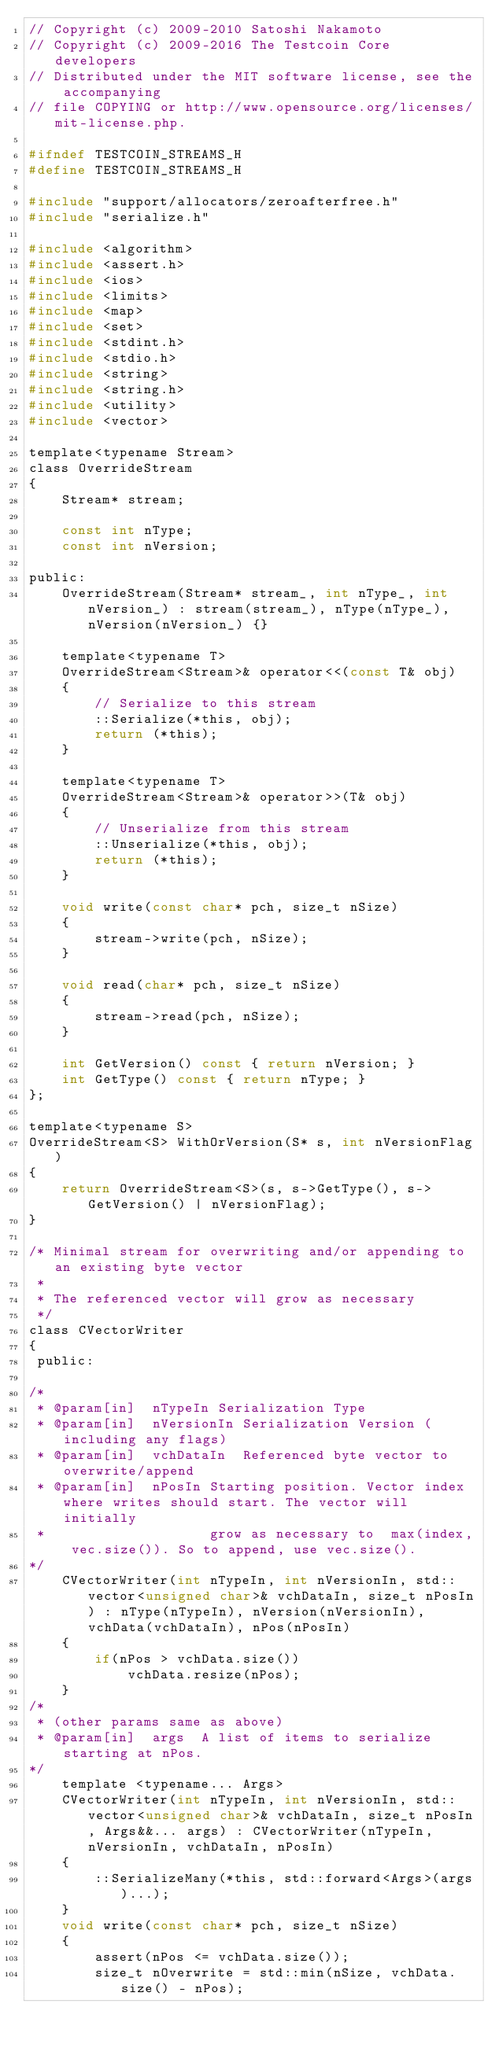<code> <loc_0><loc_0><loc_500><loc_500><_C_>// Copyright (c) 2009-2010 Satoshi Nakamoto
// Copyright (c) 2009-2016 The Testcoin Core developers
// Distributed under the MIT software license, see the accompanying
// file COPYING or http://www.opensource.org/licenses/mit-license.php.

#ifndef TESTCOIN_STREAMS_H
#define TESTCOIN_STREAMS_H

#include "support/allocators/zeroafterfree.h"
#include "serialize.h"

#include <algorithm>
#include <assert.h>
#include <ios>
#include <limits>
#include <map>
#include <set>
#include <stdint.h>
#include <stdio.h>
#include <string>
#include <string.h>
#include <utility>
#include <vector>

template<typename Stream>
class OverrideStream
{
    Stream* stream;

    const int nType;
    const int nVersion;

public:
    OverrideStream(Stream* stream_, int nType_, int nVersion_) : stream(stream_), nType(nType_), nVersion(nVersion_) {}

    template<typename T>
    OverrideStream<Stream>& operator<<(const T& obj)
    {
        // Serialize to this stream
        ::Serialize(*this, obj);
        return (*this);
    }

    template<typename T>
    OverrideStream<Stream>& operator>>(T& obj)
    {
        // Unserialize from this stream
        ::Unserialize(*this, obj);
        return (*this);
    }

    void write(const char* pch, size_t nSize)
    {
        stream->write(pch, nSize);
    }

    void read(char* pch, size_t nSize)
    {
        stream->read(pch, nSize);
    }

    int GetVersion() const { return nVersion; }
    int GetType() const { return nType; }
};

template<typename S>
OverrideStream<S> WithOrVersion(S* s, int nVersionFlag)
{
    return OverrideStream<S>(s, s->GetType(), s->GetVersion() | nVersionFlag);
}

/* Minimal stream for overwriting and/or appending to an existing byte vector
 *
 * The referenced vector will grow as necessary
 */
class CVectorWriter
{
 public:

/*
 * @param[in]  nTypeIn Serialization Type
 * @param[in]  nVersionIn Serialization Version (including any flags)
 * @param[in]  vchDataIn  Referenced byte vector to overwrite/append
 * @param[in]  nPosIn Starting position. Vector index where writes should start. The vector will initially
 *                    grow as necessary to  max(index, vec.size()). So to append, use vec.size().
*/
    CVectorWriter(int nTypeIn, int nVersionIn, std::vector<unsigned char>& vchDataIn, size_t nPosIn) : nType(nTypeIn), nVersion(nVersionIn), vchData(vchDataIn), nPos(nPosIn)
    {
        if(nPos > vchData.size())
            vchData.resize(nPos);
    }
/*
 * (other params same as above)
 * @param[in]  args  A list of items to serialize starting at nPos.
*/
    template <typename... Args>
    CVectorWriter(int nTypeIn, int nVersionIn, std::vector<unsigned char>& vchDataIn, size_t nPosIn, Args&&... args) : CVectorWriter(nTypeIn, nVersionIn, vchDataIn, nPosIn)
    {
        ::SerializeMany(*this, std::forward<Args>(args)...);
    }
    void write(const char* pch, size_t nSize)
    {
        assert(nPos <= vchData.size());
        size_t nOverwrite = std::min(nSize, vchData.size() - nPos);</code> 